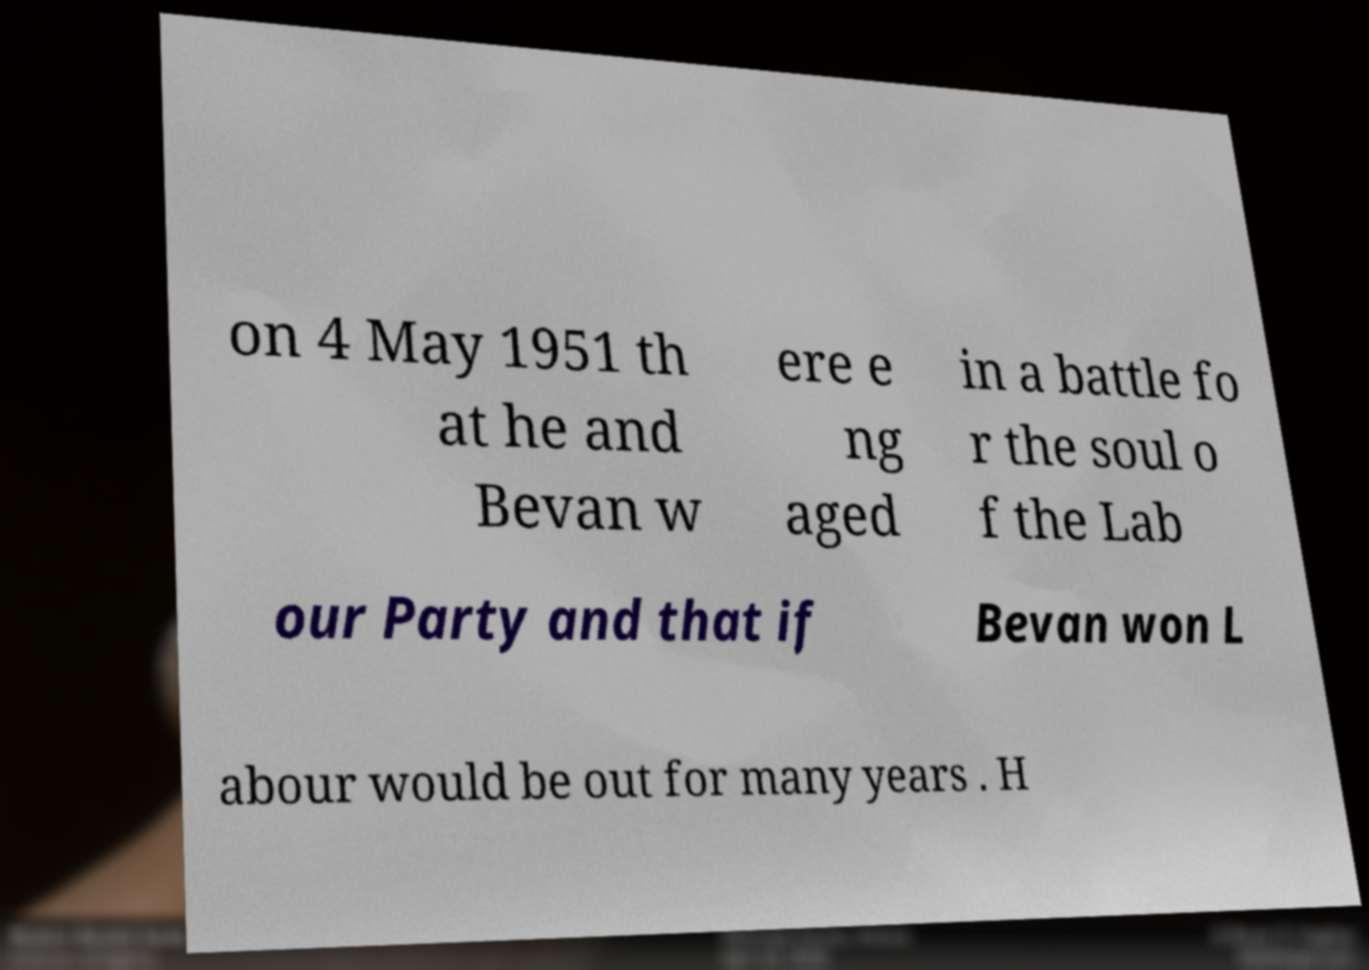Could you assist in decoding the text presented in this image and type it out clearly? on 4 May 1951 th at he and Bevan w ere e ng aged in a battle fo r the soul o f the Lab our Party and that if Bevan won L abour would be out for many years . H 